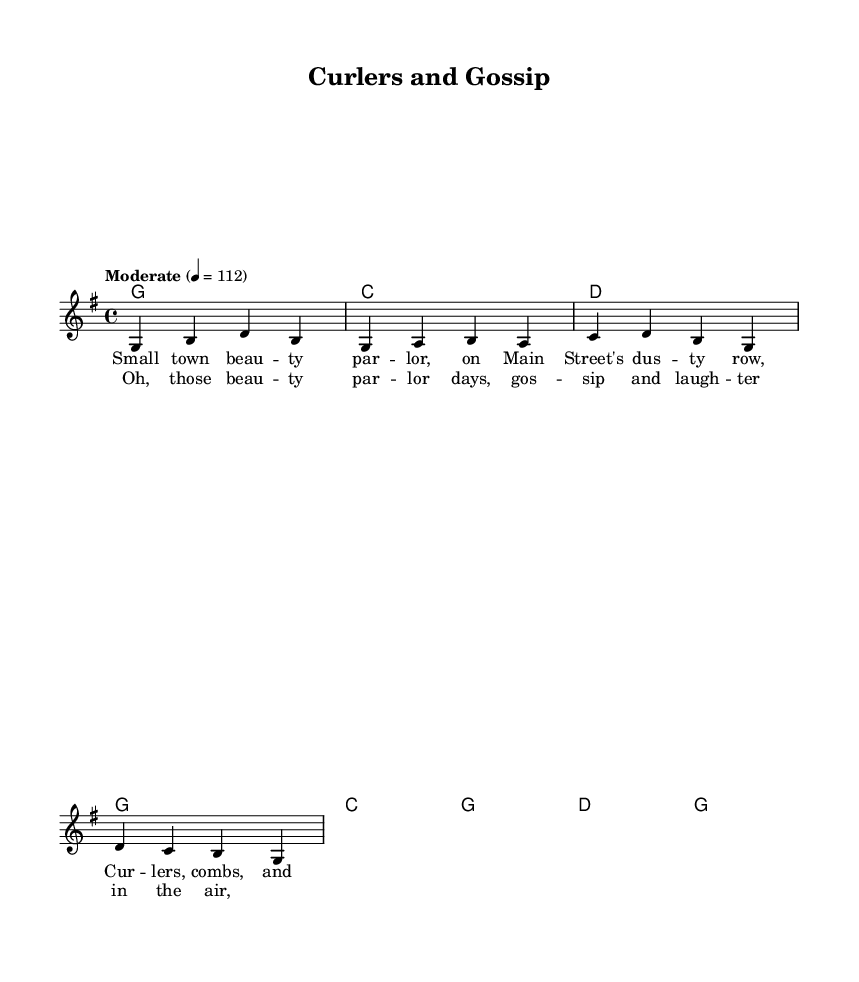What is the key signature of this music? The key signature is G major, which has one sharp (F#). This can be identified by looking at the beginning of the sheet music where the key signature is indicated by symbols.
Answer: G major What is the time signature of this music? The time signature is 4/4, as denoted in the music sheet. This means there are four beats per measure and the quarter note gets one beat.
Answer: 4/4 What is the tempo marking for this piece? The tempo marking is "Moderate", with a metronome marking of 112 beats per minute. This is typically indicated at the beginning of the score.
Answer: Moderate How many measures are in the verse melody? The verse melody consists of 8 measures, as seen in the notation where there are 8 groups of notes separated by bar lines.
Answer: 8 What is the main theme reflected in the lyrics of the song? The main theme in the lyrics revolves around nostalgia for beauty parlors. This can be deduced from the lyrical content, which focuses on memories associated with small-town beauty parlors.
Answer: Nostalgia What chords are played during the chorus section? The chords played in the chorus are C, G, D, and G. This can be identified by looking at the chord symbols above the corresponding melody notes in the chorus section.
Answer: C, G, D, G What stylistic elements are present in this country rock piece? The stylistic elements include a combination of storytelling through lyrics, catchy melodies, and a moderate tempo often found in country rock music. This style is reflected in the lyrical themes and musical arrangement.
Answer: Storytelling 